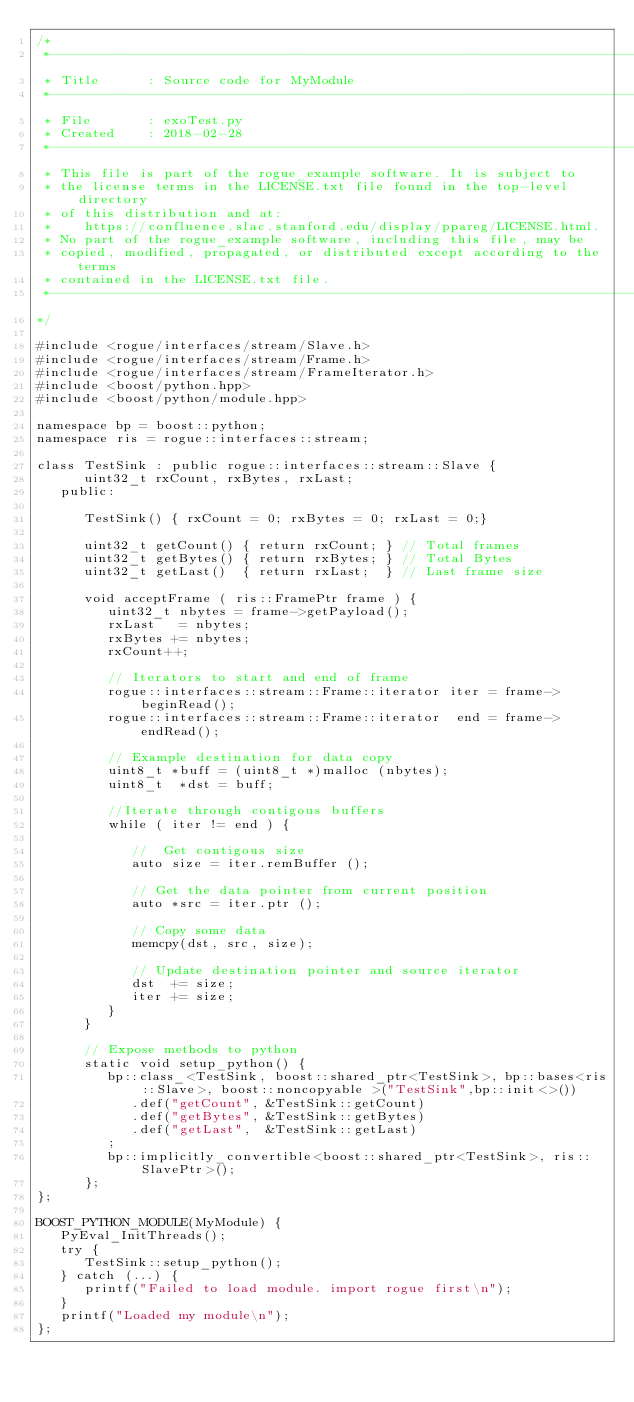<code> <loc_0><loc_0><loc_500><loc_500><_C++_>/*
 *-----------------------------------------------------------------------------
 * Title      : Source code for MyModule
 *-----------------------------------------------------------------------------
 * File       : exoTest.py
 * Created    : 2018-02-28
 *-----------------------------------------------------------------------------
 * This file is part of the rogue_example software. It is subject to
 * the license terms in the LICENSE.txt file found in the top-level directory
 * of this distribution and at:
 *    https://confluence.slac.stanford.edu/display/ppareg/LICENSE.html.
 * No part of the rogue_example software, including this file, may be
 * copied, modified, propagated, or distributed except according to the terms
 * contained in the LICENSE.txt file.
 *-----------------------------------------------------------------------------
*/

#include <rogue/interfaces/stream/Slave.h>
#include <rogue/interfaces/stream/Frame.h>
#include <rogue/interfaces/stream/FrameIterator.h>
#include <boost/python.hpp>
#include <boost/python/module.hpp>

namespace bp = boost::python;
namespace ris = rogue::interfaces::stream;

class TestSink : public rogue::interfaces::stream::Slave {
      uint32_t rxCount, rxBytes, rxLast;
   public:

      TestSink() { rxCount = 0; rxBytes = 0; rxLast = 0;}

      uint32_t getCount() { return rxCount; } // Total frames
      uint32_t getBytes() { return rxBytes; } // Total Bytes
      uint32_t getLast()  { return rxLast;  } // Last frame size

      void acceptFrame ( ris::FramePtr frame ) {
         uint32_t nbytes = frame->getPayload();
         rxLast   = nbytes;
         rxBytes += nbytes;
         rxCount++;

         // Iterators to start and end of frame
         rogue::interfaces::stream::Frame::iterator iter = frame->beginRead();
         rogue::interfaces::stream::Frame::iterator  end = frame->endRead();

         // Example destination for data copy
         uint8_t *buff = (uint8_t *)malloc (nbytes);
         uint8_t  *dst = buff;

         //Iterate through contigous buffers
         while ( iter != end ) {

            //  Get contigous size
            auto size = iter.remBuffer ();

            // Get the data pointer from current position
            auto *src = iter.ptr ();

            // Copy some data
            memcpy(dst, src, size);

            // Update destination pointer and source iterator
            dst  += size;
            iter += size;
         }
      }

      // Expose methods to python
      static void setup_python() {
         bp::class_<TestSink, boost::shared_ptr<TestSink>, bp::bases<ris::Slave>, boost::noncopyable >("TestSink",bp::init<>())
            .def("getCount", &TestSink::getCount)
            .def("getBytes", &TestSink::getBytes)
            .def("getLast",  &TestSink::getLast)
         ;
         bp::implicitly_convertible<boost::shared_ptr<TestSink>, ris::SlavePtr>();
      };
};

BOOST_PYTHON_MODULE(MyModule) {
   PyEval_InitThreads();
   try {
      TestSink::setup_python();
   } catch (...) {
      printf("Failed to load module. import rogue first\n");
   }
   printf("Loaded my module\n");
};
</code> 